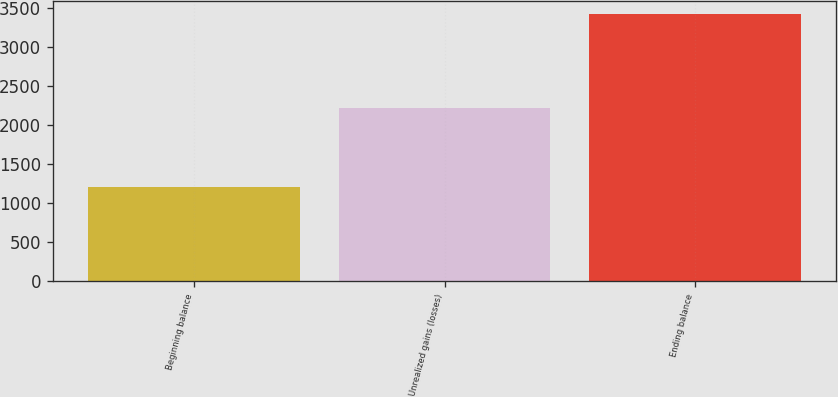Convert chart to OTSL. <chart><loc_0><loc_0><loc_500><loc_500><bar_chart><fcel>Beginning balance<fcel>Unrealized gains (losses)<fcel>Ending balance<nl><fcel>1205<fcel>2216<fcel>3421<nl></chart> 